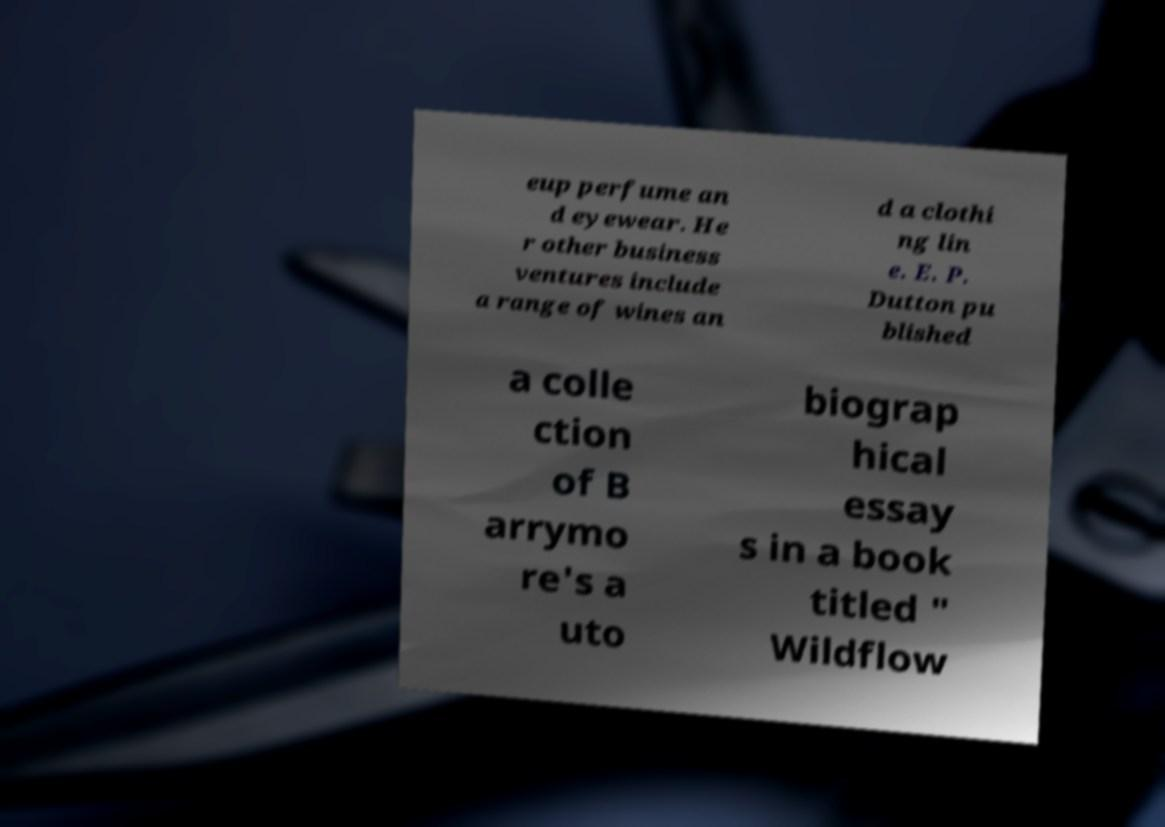For documentation purposes, I need the text within this image transcribed. Could you provide that? eup perfume an d eyewear. He r other business ventures include a range of wines an d a clothi ng lin e. E. P. Dutton pu blished a colle ction of B arrymo re's a uto biograp hical essay s in a book titled " Wildflow 